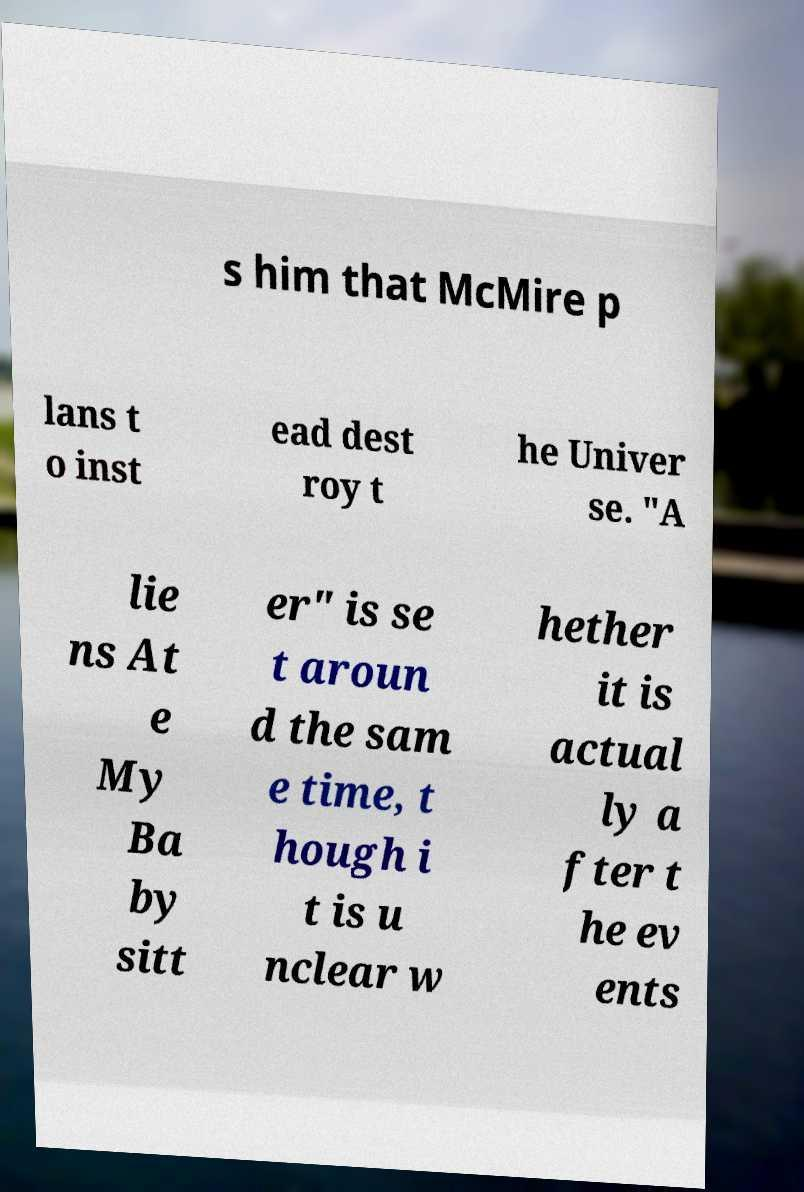Can you accurately transcribe the text from the provided image for me? s him that McMire p lans t o inst ead dest roy t he Univer se. "A lie ns At e My Ba by sitt er" is se t aroun d the sam e time, t hough i t is u nclear w hether it is actual ly a fter t he ev ents 